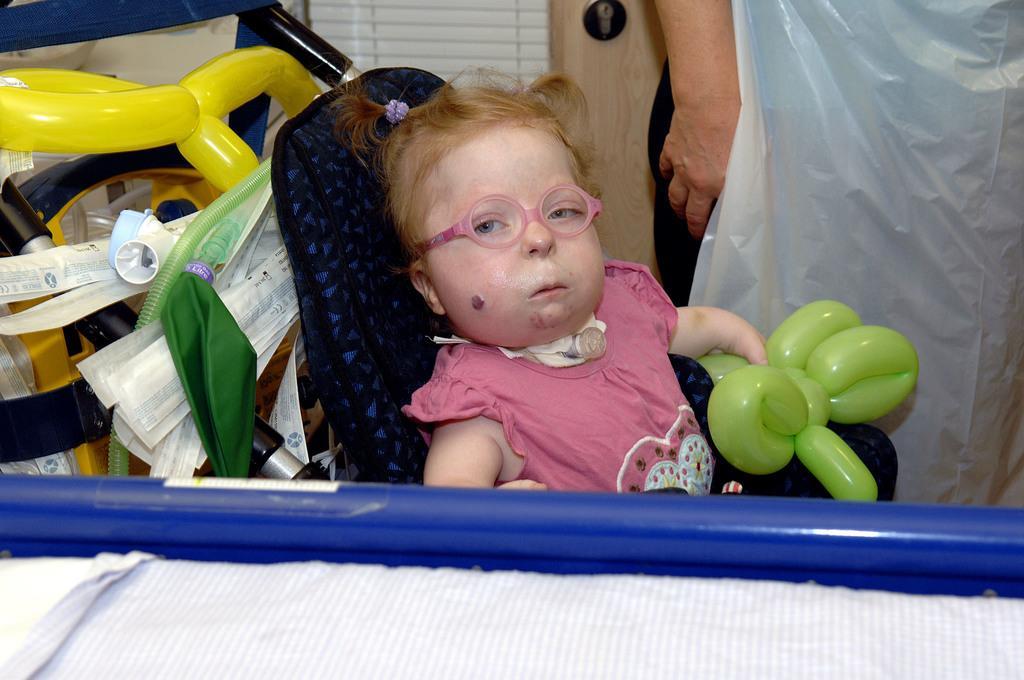Could you give a brief overview of what you see in this image? In this image there is a little girl sat on the chair and holding balloons in her hand, behind her few objects placed and there is a person standing beside the girl. 